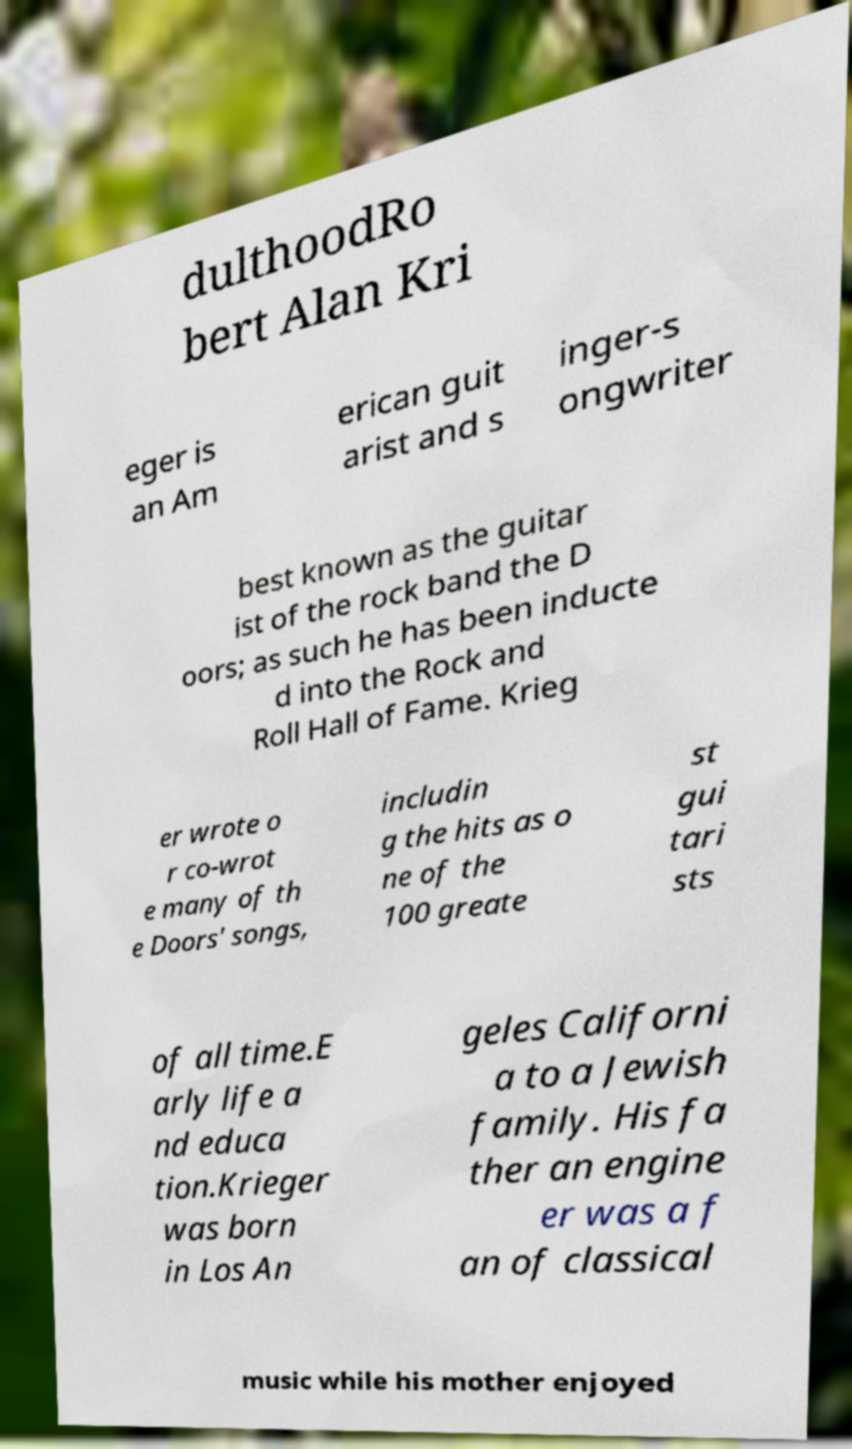Can you accurately transcribe the text from the provided image for me? dulthoodRo bert Alan Kri eger is an Am erican guit arist and s inger-s ongwriter best known as the guitar ist of the rock band the D oors; as such he has been inducte d into the Rock and Roll Hall of Fame. Krieg er wrote o r co-wrot e many of th e Doors' songs, includin g the hits as o ne of the 100 greate st gui tari sts of all time.E arly life a nd educa tion.Krieger was born in Los An geles Californi a to a Jewish family. His fa ther an engine er was a f an of classical music while his mother enjoyed 